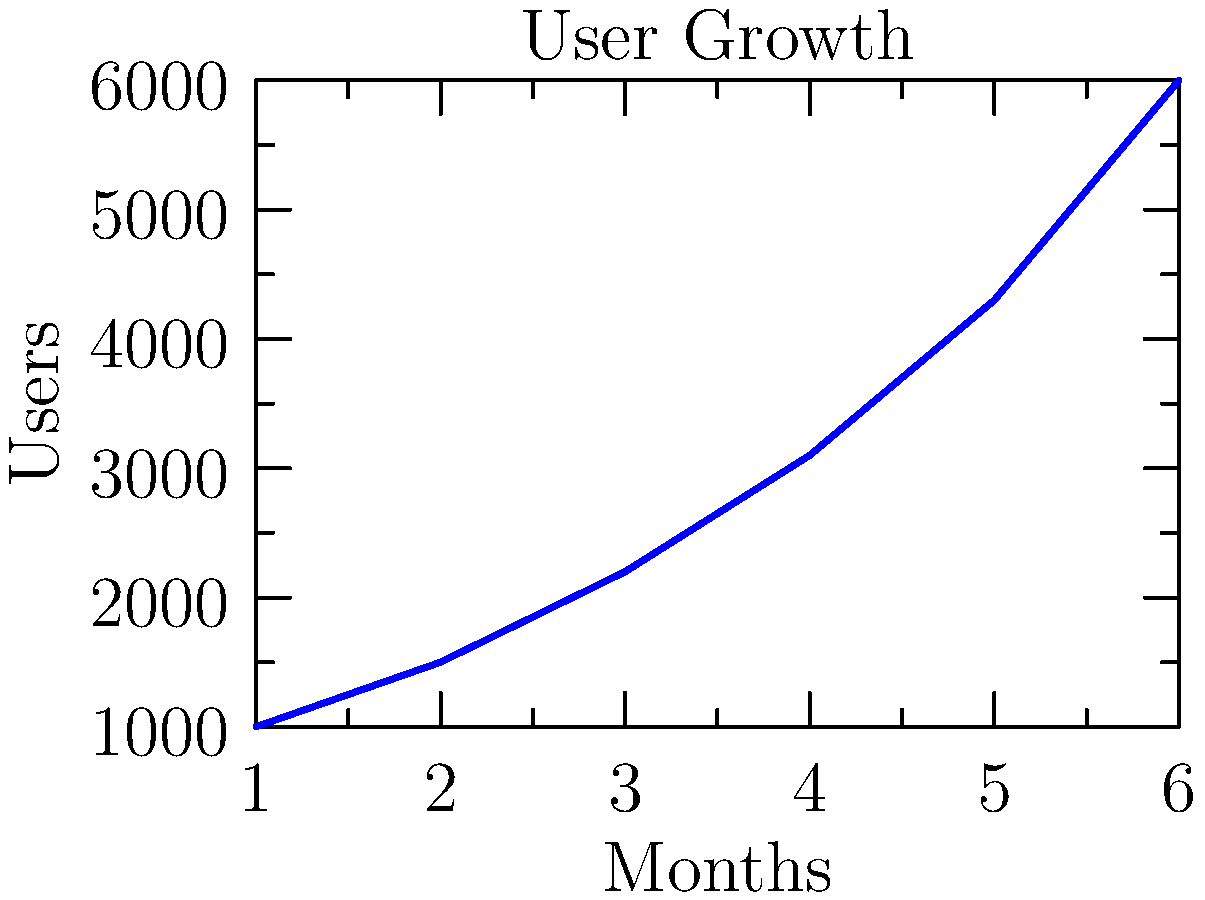Based on the line graph showing user growth over 6 months, what is the approximate percentage increase in users from month 1 to month 6? To calculate the percentage increase in users from month 1 to month 6:

1. Identify the number of users at month 1: 1,000
2. Identify the number of users at month 6: 6,000
3. Calculate the difference: 6,000 - 1,000 = 5,000
4. Divide the difference by the initial value: 5,000 / 1,000 = 5
5. Convert to percentage: 5 * 100 = 500%

The calculation can be represented as:

$$ \text{Percentage Increase} = \frac{\text{Final Value} - \text{Initial Value}}{\text{Initial Value}} \times 100\% $$

$$ = \frac{6,000 - 1,000}{1,000} \times 100\% = 500\% $$

This shows a 500% increase in users from month 1 to month 6.
Answer: 500% 